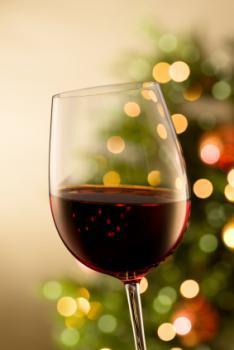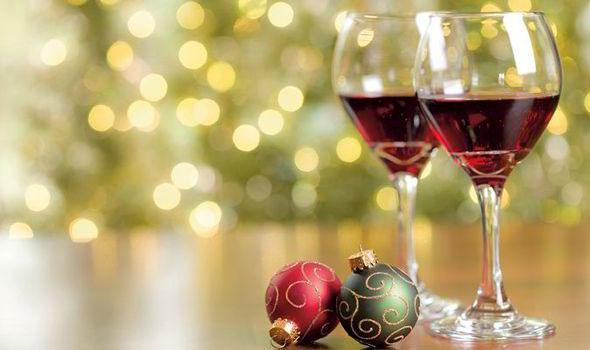The first image is the image on the left, the second image is the image on the right. For the images shown, is this caption "The right image has two wine glasses with a bottle of wine to the left of them." true? Answer yes or no. No. The first image is the image on the left, the second image is the image on the right. Assess this claim about the two images: "There are two half filled wine glasses next to the bottle in the right image.". Correct or not? Answer yes or no. No. 